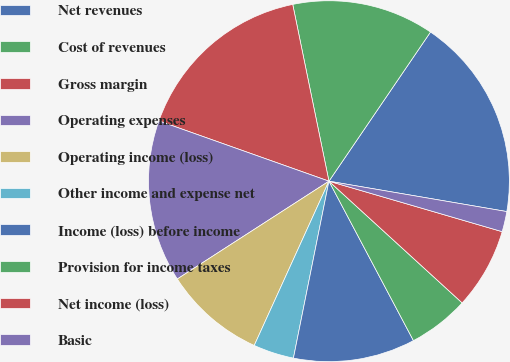<chart> <loc_0><loc_0><loc_500><loc_500><pie_chart><fcel>Net revenues<fcel>Cost of revenues<fcel>Gross margin<fcel>Operating expenses<fcel>Operating income (loss)<fcel>Other income and expense net<fcel>Income (loss) before income<fcel>Provision for income taxes<fcel>Net income (loss)<fcel>Basic<nl><fcel>18.18%<fcel>12.73%<fcel>16.36%<fcel>14.54%<fcel>9.09%<fcel>3.64%<fcel>10.91%<fcel>5.46%<fcel>7.27%<fcel>1.82%<nl></chart> 